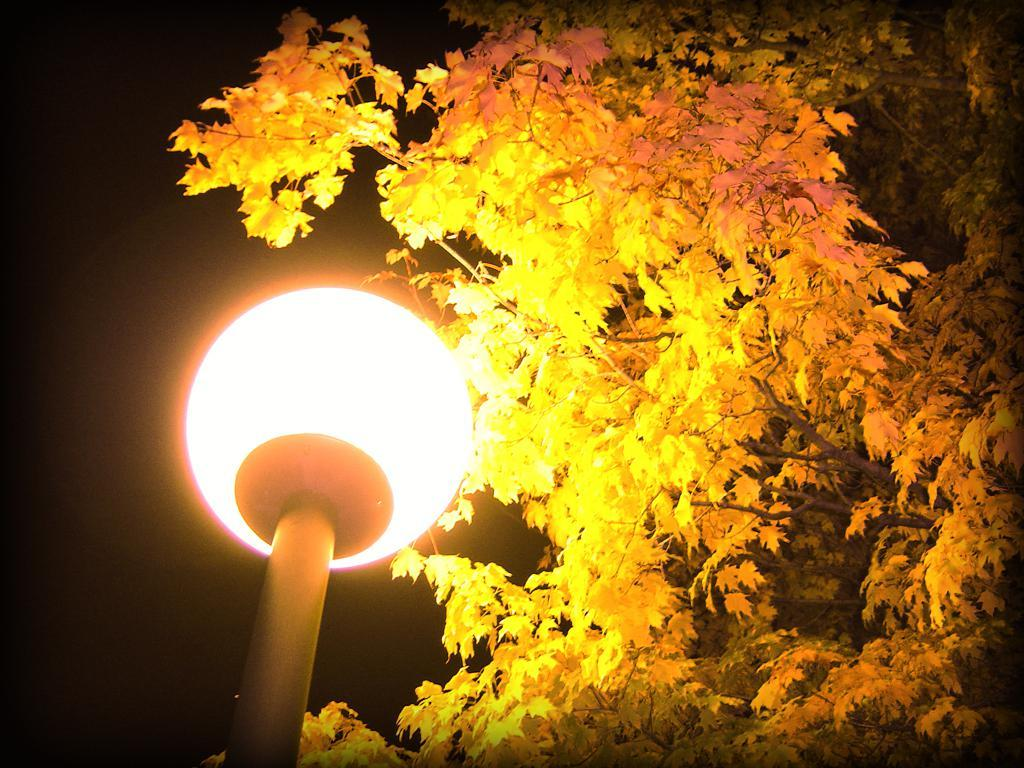What type of structure is visible in the image? There is a street light in the image. What natural element can be seen in the image? There is a tree in the image. What is the mind of the tree thinking in the image? Trees do not have minds or thoughts, so this question cannot be answered. 